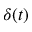<formula> <loc_0><loc_0><loc_500><loc_500>\delta ( t )</formula> 